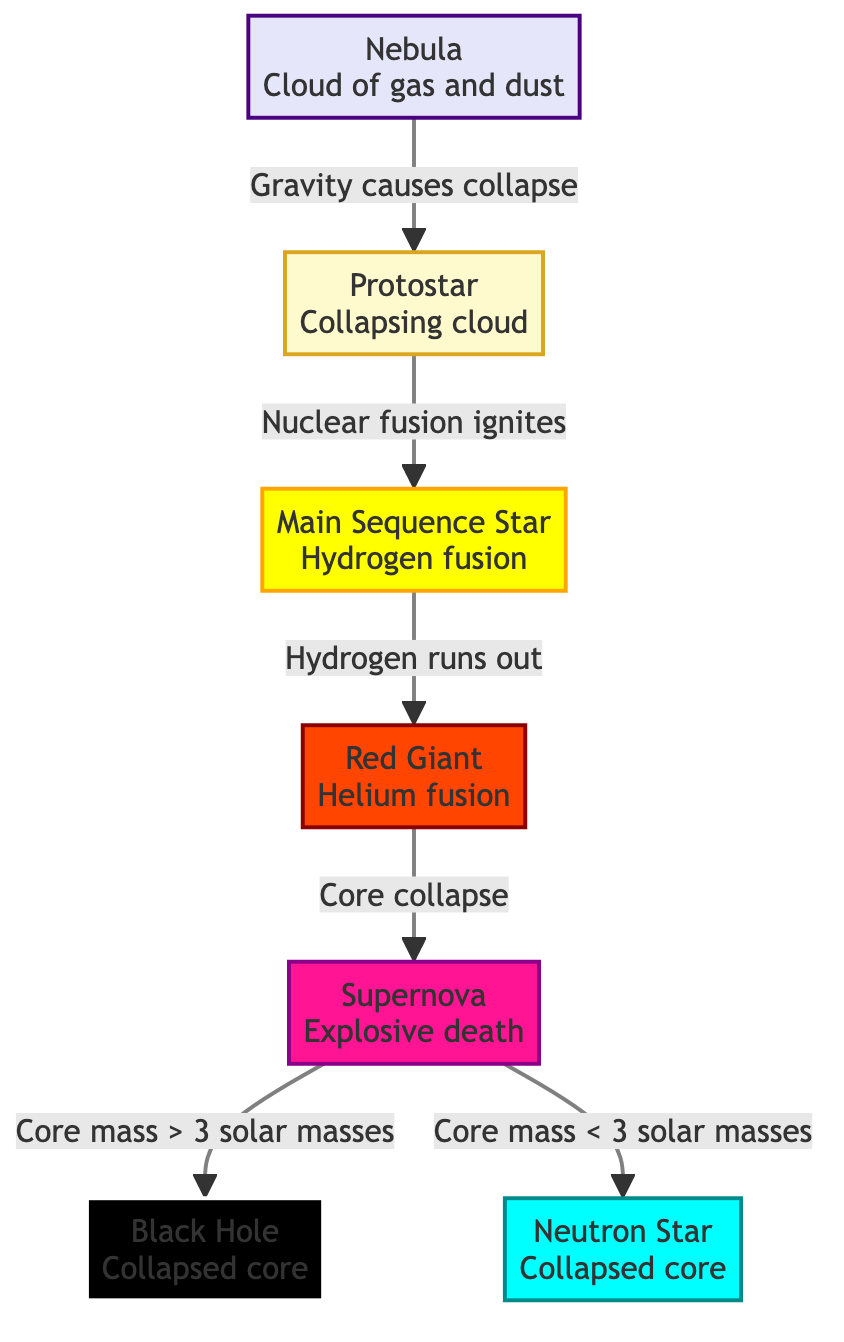What is the first stage of a star's lifecycle? The first stage of a star's lifecycle is represented by the node labeled "Nebula," indicating that it begins as a cloud of gas and dust.
Answer: Nebula What follows the protostar stage? According to the flowchart, after the protostar stage, the next stage is the "Main Sequence Star," where nuclear fusion ignites.
Answer: Main Sequence Star What happens to the star when hydrogen runs out? The diagram states that when hydrogen runs out, the star transitions into the "Red Giant" stage, indicating the process of helium fusion.
Answer: Red Giant What is the outcome of a supernova with core mass greater than 3 solar masses? From the diagram, a supernova with a core mass greater than 3 solar masses leads to the formation of a "Black Hole."
Answer: Black Hole How many outcomes are there after a supernova event based on core mass? The diagram shows two outcomes from a supernova based on core mass: either a black hole or a neutron star. Therefore, there are two outcomes.
Answer: 2 What causes the protostar to ignite nuclear fusion? The flowchart indicates that nuclear fusion ignites in the protostar stage due to the collapsing cloud, which is driven by gravity.
Answer: Gravity causes collapse What is the relationship between the main sequence star and the red giant? The relationship is sequential; when a main sequence star's hydrogen runs out, it transitions into the red giant stage.
Answer: Sequential transition What color represents the neutron star in the diagram? In the diagram, the color representing the neutron star is cyan.
Answer: Cyan Which stage is associated with explosive death? The stage associated with explosive death is labeled "Supernova" in the diagram.
Answer: Supernova What is the collapse core's fate for a star with a mass less than 3 solar masses after a supernova? After a supernova, a star with a core mass less than 3 solar masses results in the formation of a "Neutron Star."
Answer: Neutron Star 